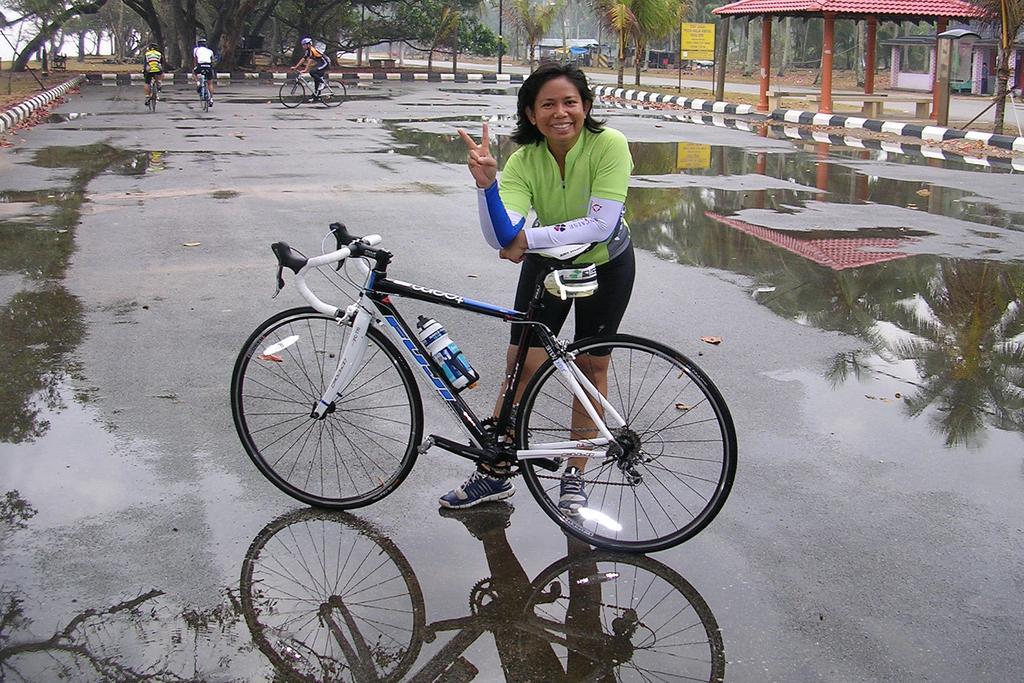Can you describe this image briefly? In this picture there is a woman standing and smiling, in front of her we can see a bicycle on the road and we can see water, on the water we can see reflection of trees. In the background of the image there are people riding bicycles and wore helmets and we can see trees, board, sheds and poles. 